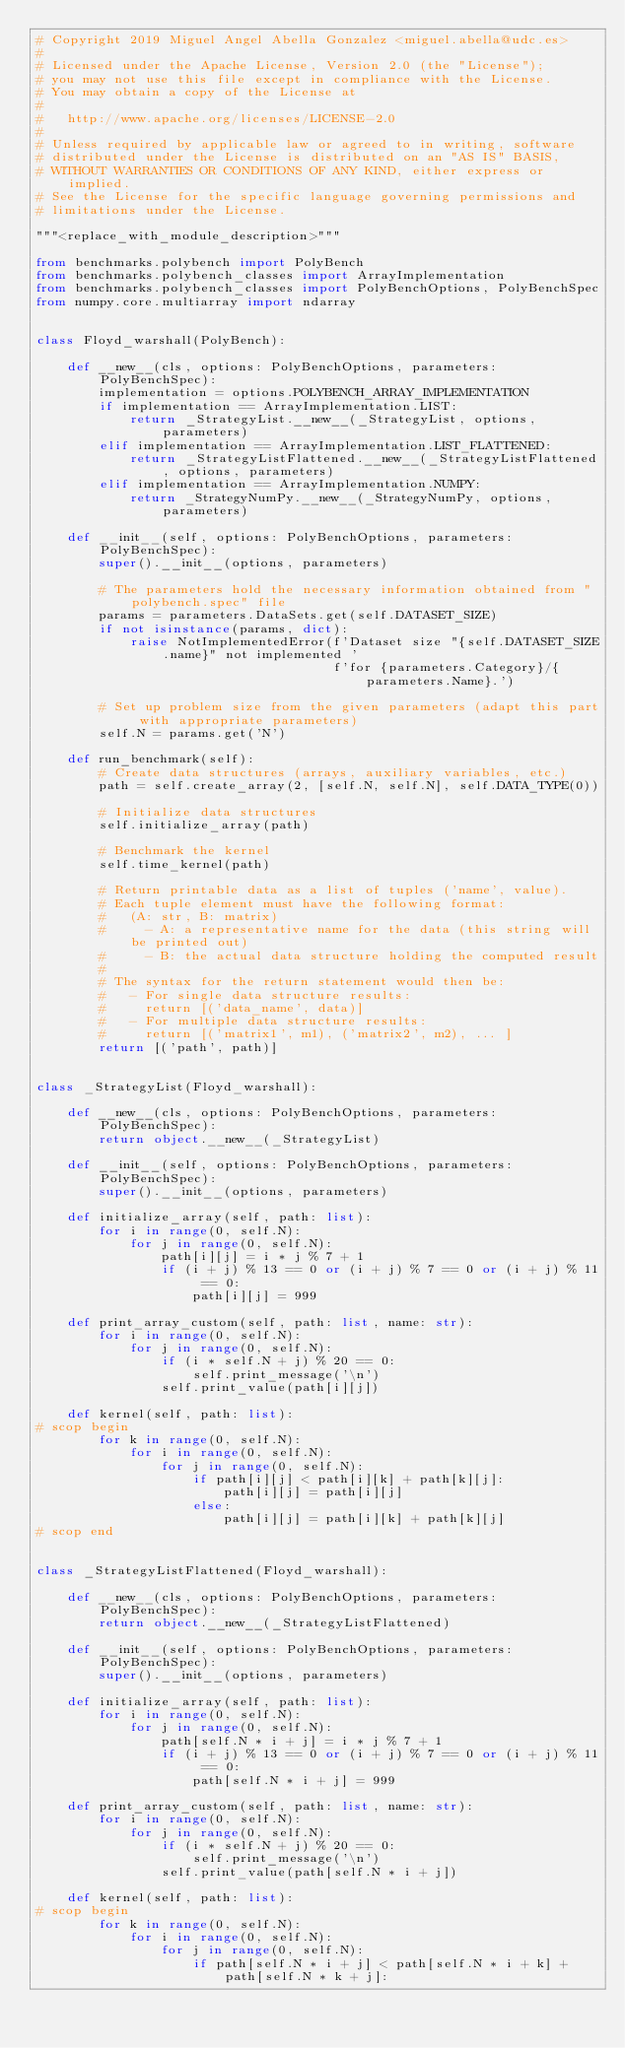Convert code to text. <code><loc_0><loc_0><loc_500><loc_500><_Python_># Copyright 2019 Miguel Angel Abella Gonzalez <miguel.abella@udc.es>
#
# Licensed under the Apache License, Version 2.0 (the "License");
# you may not use this file except in compliance with the License.
# You may obtain a copy of the License at
#
#   http://www.apache.org/licenses/LICENSE-2.0
#
# Unless required by applicable law or agreed to in writing, software
# distributed under the License is distributed on an "AS IS" BASIS,
# WITHOUT WARRANTIES OR CONDITIONS OF ANY KIND, either express or implied.
# See the License for the specific language governing permissions and
# limitations under the License.

"""<replace_with_module_description>"""

from benchmarks.polybench import PolyBench
from benchmarks.polybench_classes import ArrayImplementation
from benchmarks.polybench_classes import PolyBenchOptions, PolyBenchSpec
from numpy.core.multiarray import ndarray


class Floyd_warshall(PolyBench):

    def __new__(cls, options: PolyBenchOptions, parameters: PolyBenchSpec):
        implementation = options.POLYBENCH_ARRAY_IMPLEMENTATION
        if implementation == ArrayImplementation.LIST:
            return _StrategyList.__new__(_StrategyList, options, parameters)
        elif implementation == ArrayImplementation.LIST_FLATTENED:
            return _StrategyListFlattened.__new__(_StrategyListFlattened, options, parameters)
        elif implementation == ArrayImplementation.NUMPY:
            return _StrategyNumPy.__new__(_StrategyNumPy, options, parameters)

    def __init__(self, options: PolyBenchOptions, parameters: PolyBenchSpec):
        super().__init__(options, parameters)

        # The parameters hold the necessary information obtained from "polybench.spec" file
        params = parameters.DataSets.get(self.DATASET_SIZE)
        if not isinstance(params, dict):
            raise NotImplementedError(f'Dataset size "{self.DATASET_SIZE.name}" not implemented '
                                      f'for {parameters.Category}/{parameters.Name}.')

        # Set up problem size from the given parameters (adapt this part with appropriate parameters)
        self.N = params.get('N')

    def run_benchmark(self):
        # Create data structures (arrays, auxiliary variables, etc.)
        path = self.create_array(2, [self.N, self.N], self.DATA_TYPE(0))

        # Initialize data structures
        self.initialize_array(path)

        # Benchmark the kernel
        self.time_kernel(path)

        # Return printable data as a list of tuples ('name', value).
        # Each tuple element must have the following format:
        #   (A: str, B: matrix)
        #     - A: a representative name for the data (this string will be printed out)
        #     - B: the actual data structure holding the computed result
        #
        # The syntax for the return statement would then be:
        #   - For single data structure results:
        #     return [('data_name', data)]
        #   - For multiple data structure results:
        #     return [('matrix1', m1), ('matrix2', m2), ... ]
        return [('path', path)]


class _StrategyList(Floyd_warshall):

    def __new__(cls, options: PolyBenchOptions, parameters: PolyBenchSpec):
        return object.__new__(_StrategyList)

    def __init__(self, options: PolyBenchOptions, parameters: PolyBenchSpec):
        super().__init__(options, parameters)

    def initialize_array(self, path: list):
        for i in range(0, self.N):
            for j in range(0, self.N):
                path[i][j] = i * j % 7 + 1
                if (i + j) % 13 == 0 or (i + j) % 7 == 0 or (i + j) % 11 == 0:
                    path[i][j] = 999

    def print_array_custom(self, path: list, name: str):
        for i in range(0, self.N):
            for j in range(0, self.N):
                if (i * self.N + j) % 20 == 0:
                    self.print_message('\n')
                self.print_value(path[i][j])

    def kernel(self, path: list):
# scop begin
        for k in range(0, self.N):
            for i in range(0, self.N):
                for j in range(0, self.N):
                    if path[i][j] < path[i][k] + path[k][j]:
                        path[i][j] = path[i][j]
                    else:
                        path[i][j] = path[i][k] + path[k][j]
# scop end


class _StrategyListFlattened(Floyd_warshall):

    def __new__(cls, options: PolyBenchOptions, parameters: PolyBenchSpec):
        return object.__new__(_StrategyListFlattened)

    def __init__(self, options: PolyBenchOptions, parameters: PolyBenchSpec):
        super().__init__(options, parameters)

    def initialize_array(self, path: list):
        for i in range(0, self.N):
            for j in range(0, self.N):
                path[self.N * i + j] = i * j % 7 + 1
                if (i + j) % 13 == 0 or (i + j) % 7 == 0 or (i + j) % 11 == 0:
                    path[self.N * i + j] = 999

    def print_array_custom(self, path: list, name: str):
        for i in range(0, self.N):
            for j in range(0, self.N):
                if (i * self.N + j) % 20 == 0:
                    self.print_message('\n')
                self.print_value(path[self.N * i + j])

    def kernel(self, path: list):
# scop begin
        for k in range(0, self.N):
            for i in range(0, self.N):
                for j in range(0, self.N):
                    if path[self.N * i + j] < path[self.N * i + k] + path[self.N * k + j]:</code> 